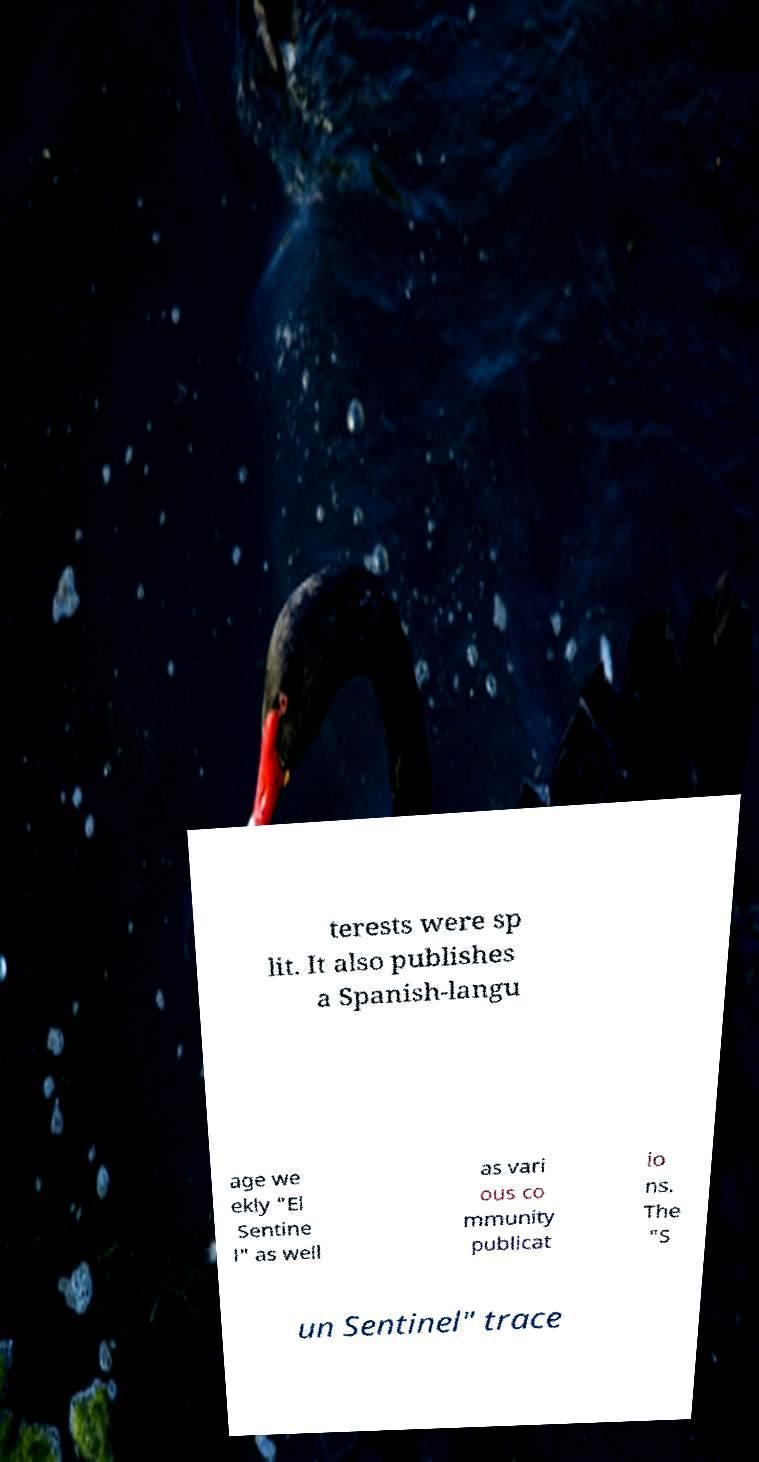I need the written content from this picture converted into text. Can you do that? terests were sp lit. It also publishes a Spanish-langu age we ekly "El Sentine l" as well as vari ous co mmunity publicat io ns. The "S un Sentinel" trace 